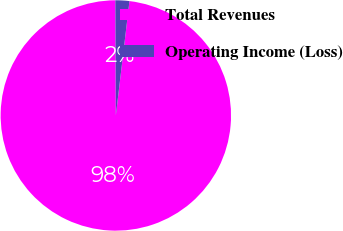<chart> <loc_0><loc_0><loc_500><loc_500><pie_chart><fcel>Total Revenues<fcel>Operating Income (Loss)<nl><fcel>98.04%<fcel>1.96%<nl></chart> 